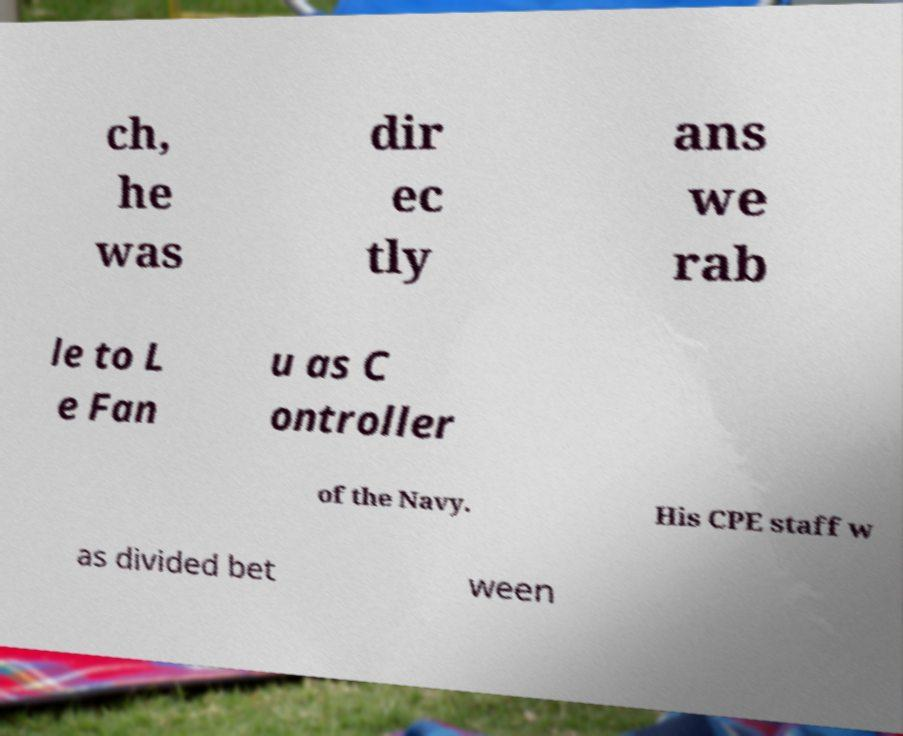Could you assist in decoding the text presented in this image and type it out clearly? ch, he was dir ec tly ans we rab le to L e Fan u as C ontroller of the Navy. His CPE staff w as divided bet ween 